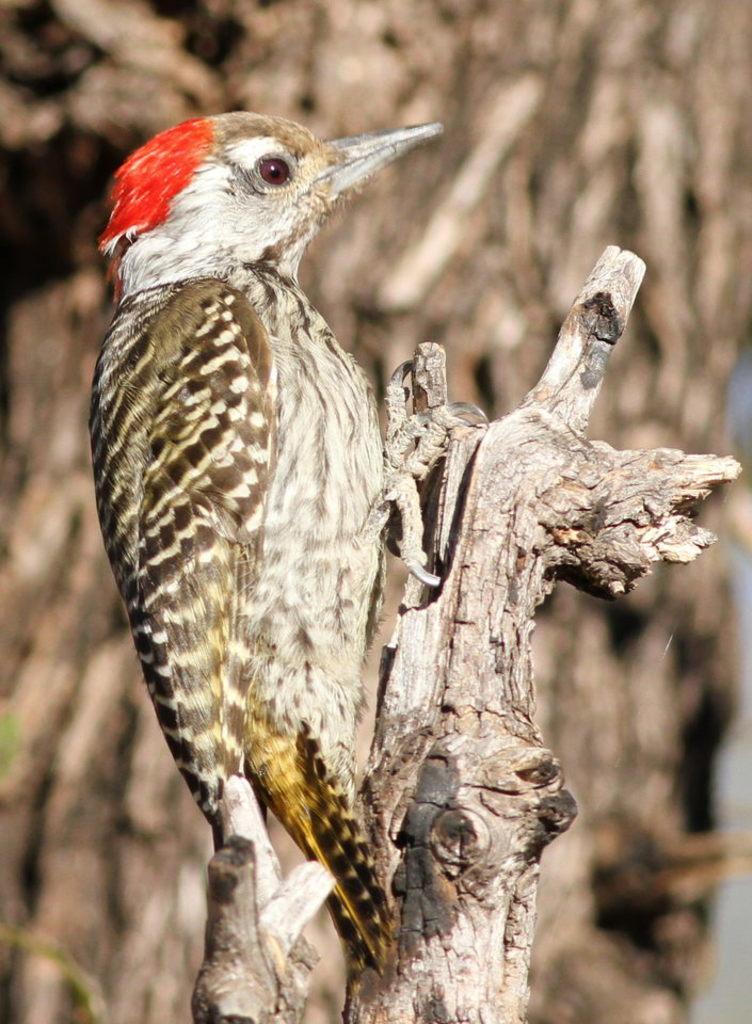Describe this image in one or two sentences. In this picture we can see red headed woodpecker standing on this wood. In the background we can see tree. 